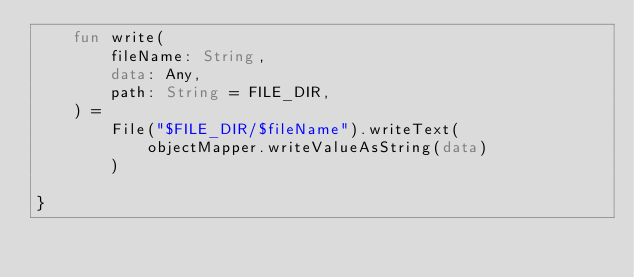<code> <loc_0><loc_0><loc_500><loc_500><_Kotlin_>    fun write(
        fileName: String,
        data: Any,
        path: String = FILE_DIR,
    ) =
        File("$FILE_DIR/$fileName").writeText(
            objectMapper.writeValueAsString(data)
        )

}</code> 